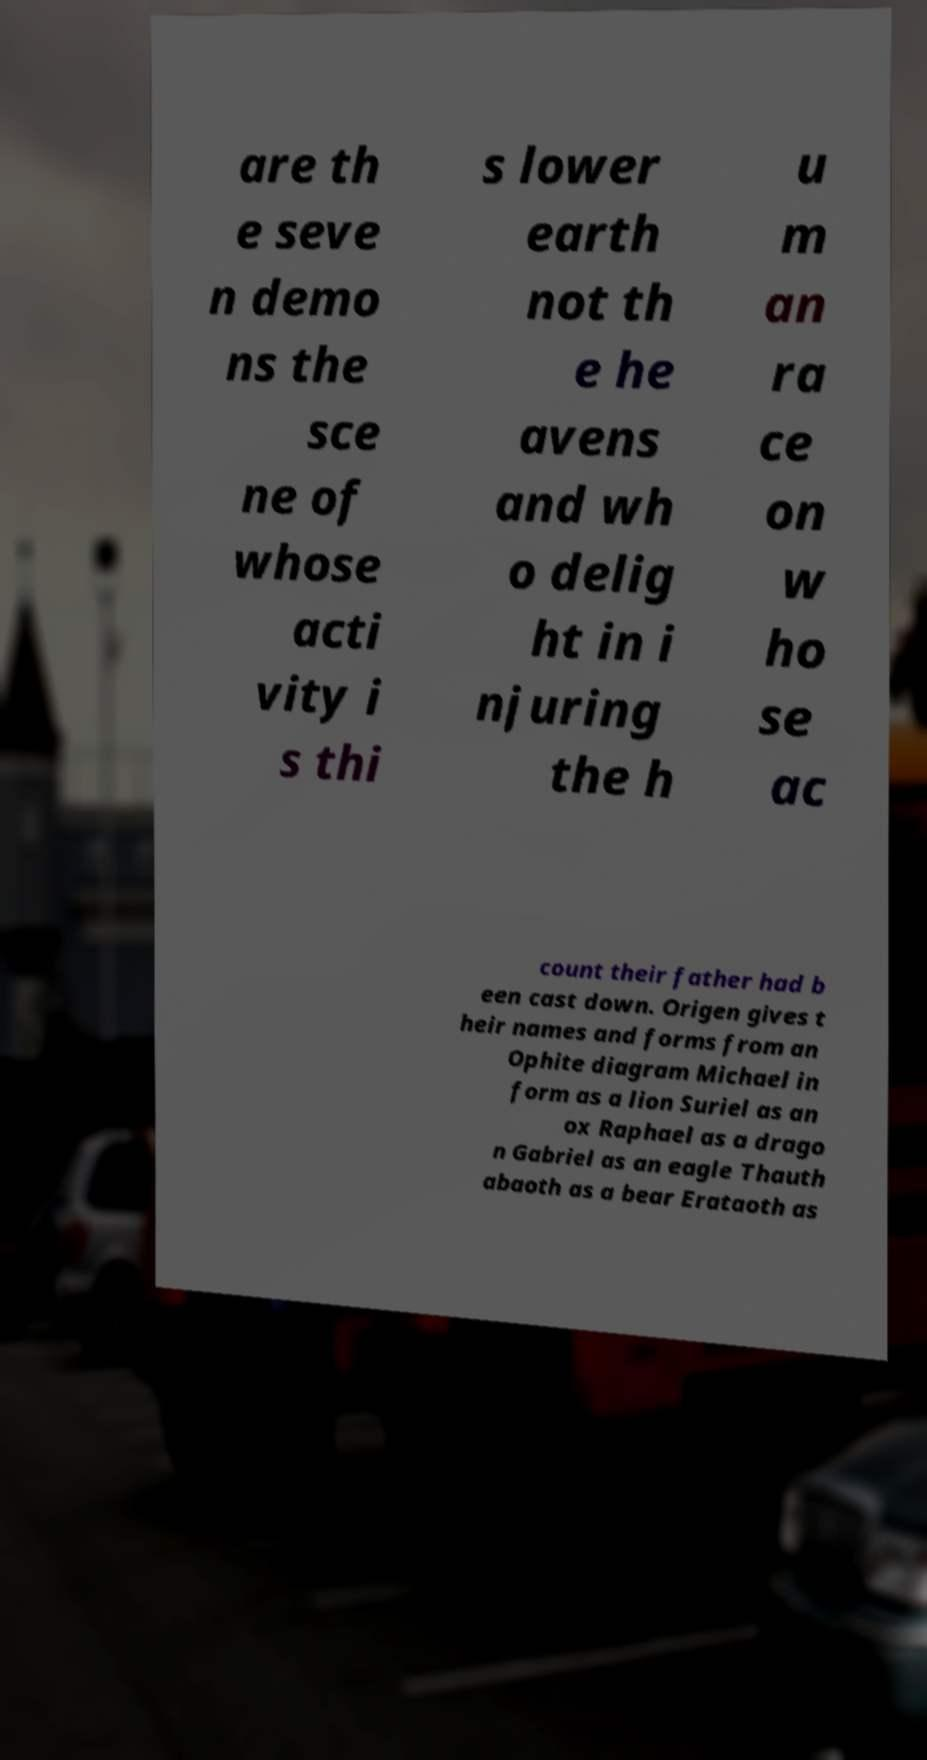What messages or text are displayed in this image? I need them in a readable, typed format. are th e seve n demo ns the sce ne of whose acti vity i s thi s lower earth not th e he avens and wh o delig ht in i njuring the h u m an ra ce on w ho se ac count their father had b een cast down. Origen gives t heir names and forms from an Ophite diagram Michael in form as a lion Suriel as an ox Raphael as a drago n Gabriel as an eagle Thauth abaoth as a bear Erataoth as 